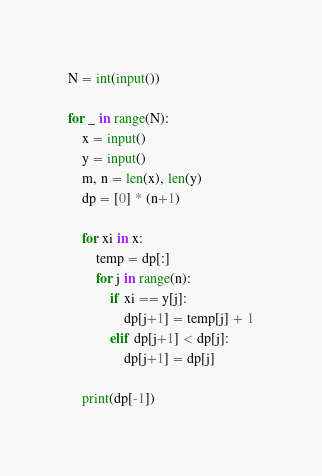Convert code to text. <code><loc_0><loc_0><loc_500><loc_500><_Python_>N = int(input())

for _ in range(N):
    x = input()
    y = input()
    m, n = len(x), len(y)
    dp = [0] * (n+1)
    
    for xi in x:
        temp = dp[:]
        for j in range(n):
            if xi == y[j]:
                dp[j+1] = temp[j] + 1
            elif dp[j+1] < dp[j]:
                dp[j+1] = dp[j]
                
    print(dp[-1])</code> 